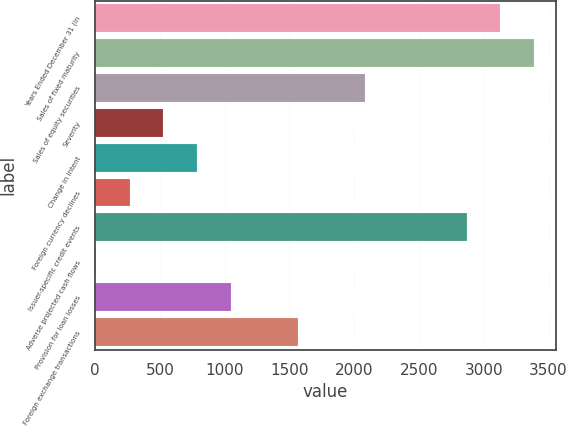<chart> <loc_0><loc_0><loc_500><loc_500><bar_chart><fcel>Years Ended December 31 (in<fcel>Sales of fixed maturity<fcel>Sales of equity securities<fcel>Severity<fcel>Change in intent<fcel>Foreign currency declines<fcel>Issuer-specific credit events<fcel>Adverse projected cash flows<fcel>Provision for loan losses<fcel>Foreign exchange transactions<nl><fcel>3127.4<fcel>3387.6<fcel>2086.6<fcel>525.4<fcel>785.6<fcel>265.2<fcel>2867.2<fcel>5<fcel>1045.8<fcel>1566.2<nl></chart> 